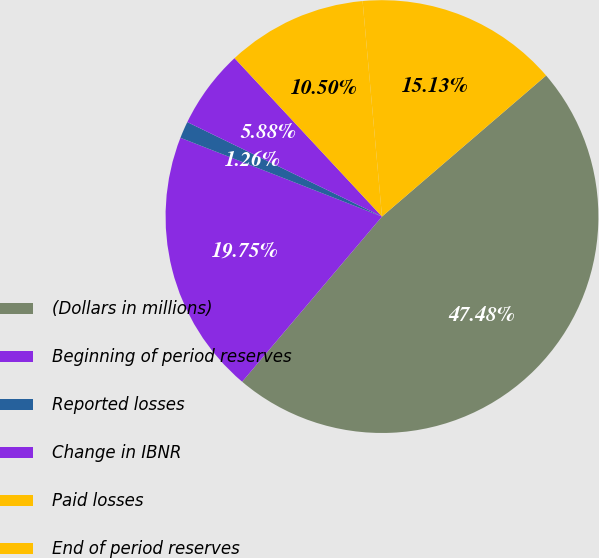<chart> <loc_0><loc_0><loc_500><loc_500><pie_chart><fcel>(Dollars in millions)<fcel>Beginning of period reserves<fcel>Reported losses<fcel>Change in IBNR<fcel>Paid losses<fcel>End of period reserves<nl><fcel>47.48%<fcel>19.75%<fcel>1.26%<fcel>5.88%<fcel>10.5%<fcel>15.13%<nl></chart> 